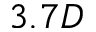<formula> <loc_0><loc_0><loc_500><loc_500>3 . 7 D</formula> 